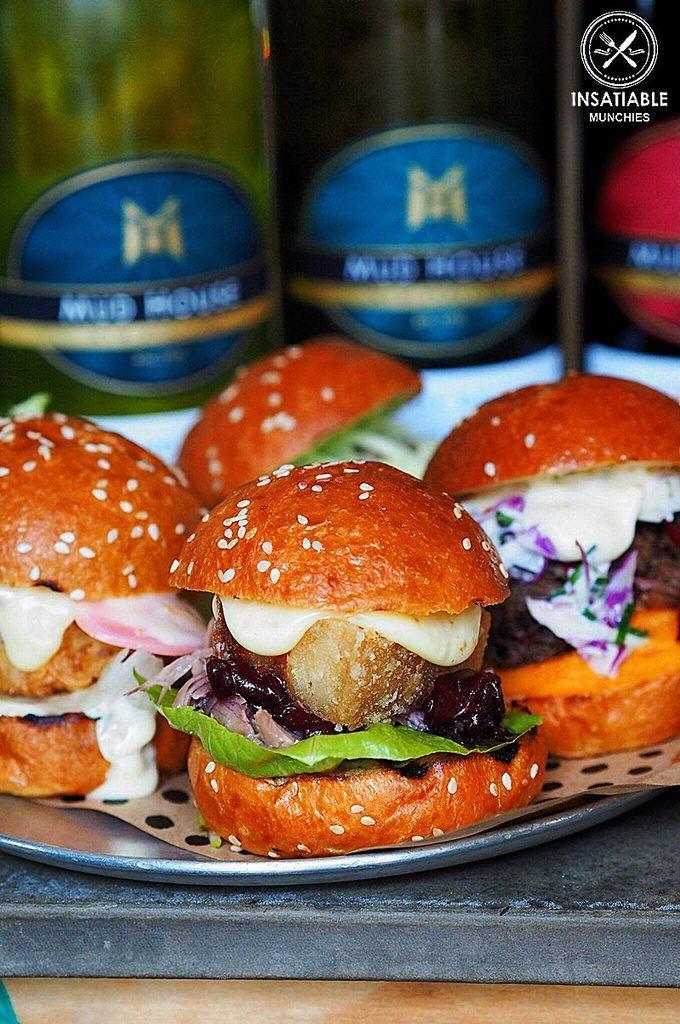Describe this image in one or two sentences. In this image we can see some burgers in a plate which is placed on the surface. On the backside we can see some bottles and some text on it. 